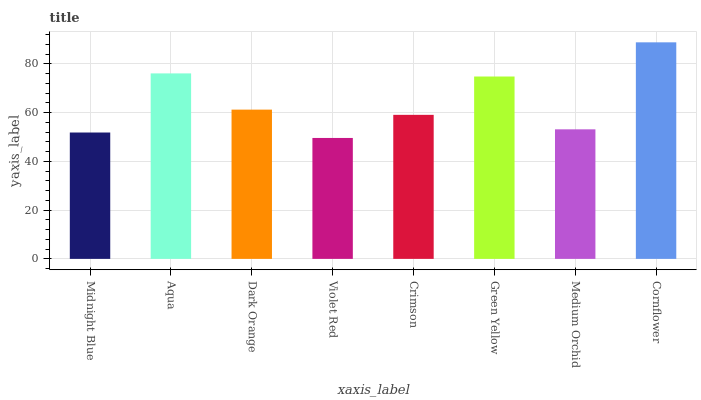Is Aqua the minimum?
Answer yes or no. No. Is Aqua the maximum?
Answer yes or no. No. Is Aqua greater than Midnight Blue?
Answer yes or no. Yes. Is Midnight Blue less than Aqua?
Answer yes or no. Yes. Is Midnight Blue greater than Aqua?
Answer yes or no. No. Is Aqua less than Midnight Blue?
Answer yes or no. No. Is Dark Orange the high median?
Answer yes or no. Yes. Is Crimson the low median?
Answer yes or no. Yes. Is Violet Red the high median?
Answer yes or no. No. Is Aqua the low median?
Answer yes or no. No. 